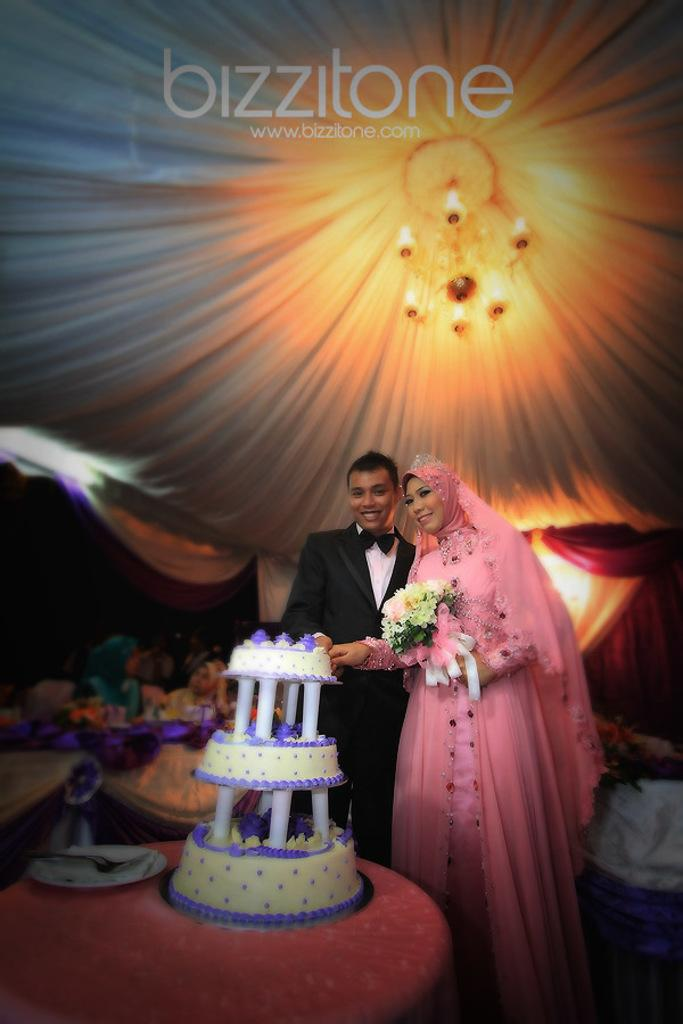How many people are present in the image? There are two people in the image, a man and a woman. What is one of the women holding in her hand? One woman is holding a flower vase in her hand. What can be seen on the table in the image? There is a cake on a table in the image. What type of objects can be seen in the image that are typically associated with children? There are toys visible in the image. What material is present in the image that might be used for decoration or covering? There is a cloth in the image. What type of toothpaste is visible in the image? There is no toothpaste present in the image. Can you describe the veins of the woman holding the flower vase? There is no mention of the woman's veins in the image, and it is not possible to see them through her skin. What kind of bird is perched on the cake in the image? There is no bird, specifically a wren, present in the image. 